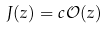<formula> <loc_0><loc_0><loc_500><loc_500>J ( z ) = c \mathcal { O } ( z )</formula> 